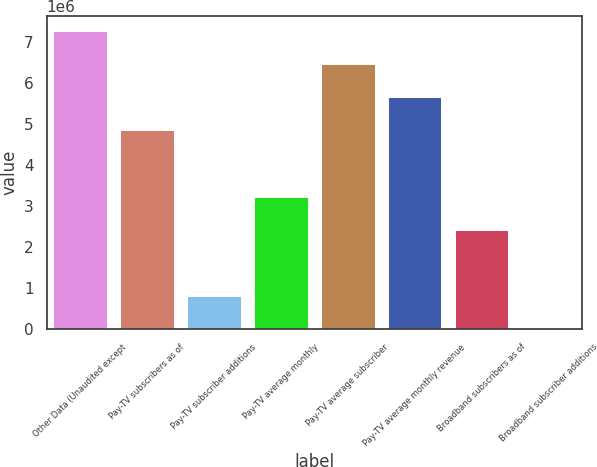Convert chart. <chart><loc_0><loc_0><loc_500><loc_500><bar_chart><fcel>Other Data (Unaudited except<fcel>Pay-TV subscribers as of<fcel>Pay-TV subscriber additions<fcel>Pay-TV average monthly<fcel>Pay-TV average subscriber<fcel>Pay-TV average monthly revenue<fcel>Broadband subscribers as of<fcel>Broadband subscriber additions<nl><fcel>7.26673e+06<fcel>4.84449e+06<fcel>807415<fcel>3.22966e+06<fcel>6.45932e+06<fcel>5.6519e+06<fcel>2.42224e+06<fcel>0.05<nl></chart> 